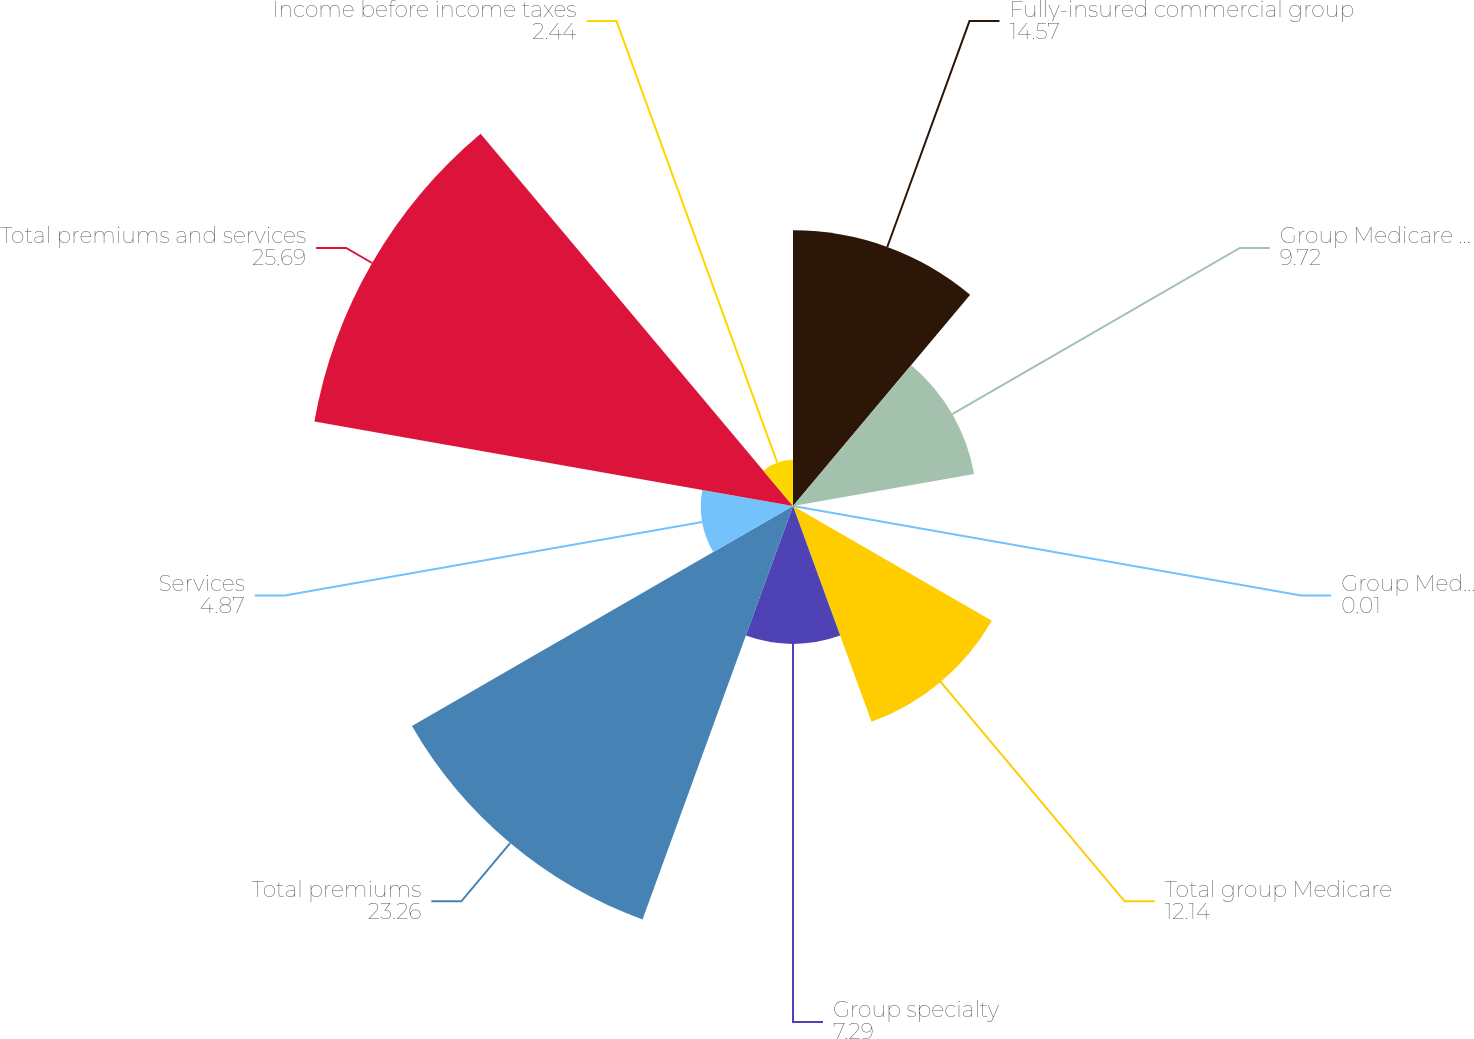<chart> <loc_0><loc_0><loc_500><loc_500><pie_chart><fcel>Fully-insured commercial group<fcel>Group Medicare Advantage<fcel>Group Medicare stand-alone PDP<fcel>Total group Medicare<fcel>Group specialty<fcel>Total premiums<fcel>Services<fcel>Total premiums and services<fcel>Income before income taxes<nl><fcel>14.57%<fcel>9.72%<fcel>0.01%<fcel>12.14%<fcel>7.29%<fcel>23.26%<fcel>4.87%<fcel>25.69%<fcel>2.44%<nl></chart> 